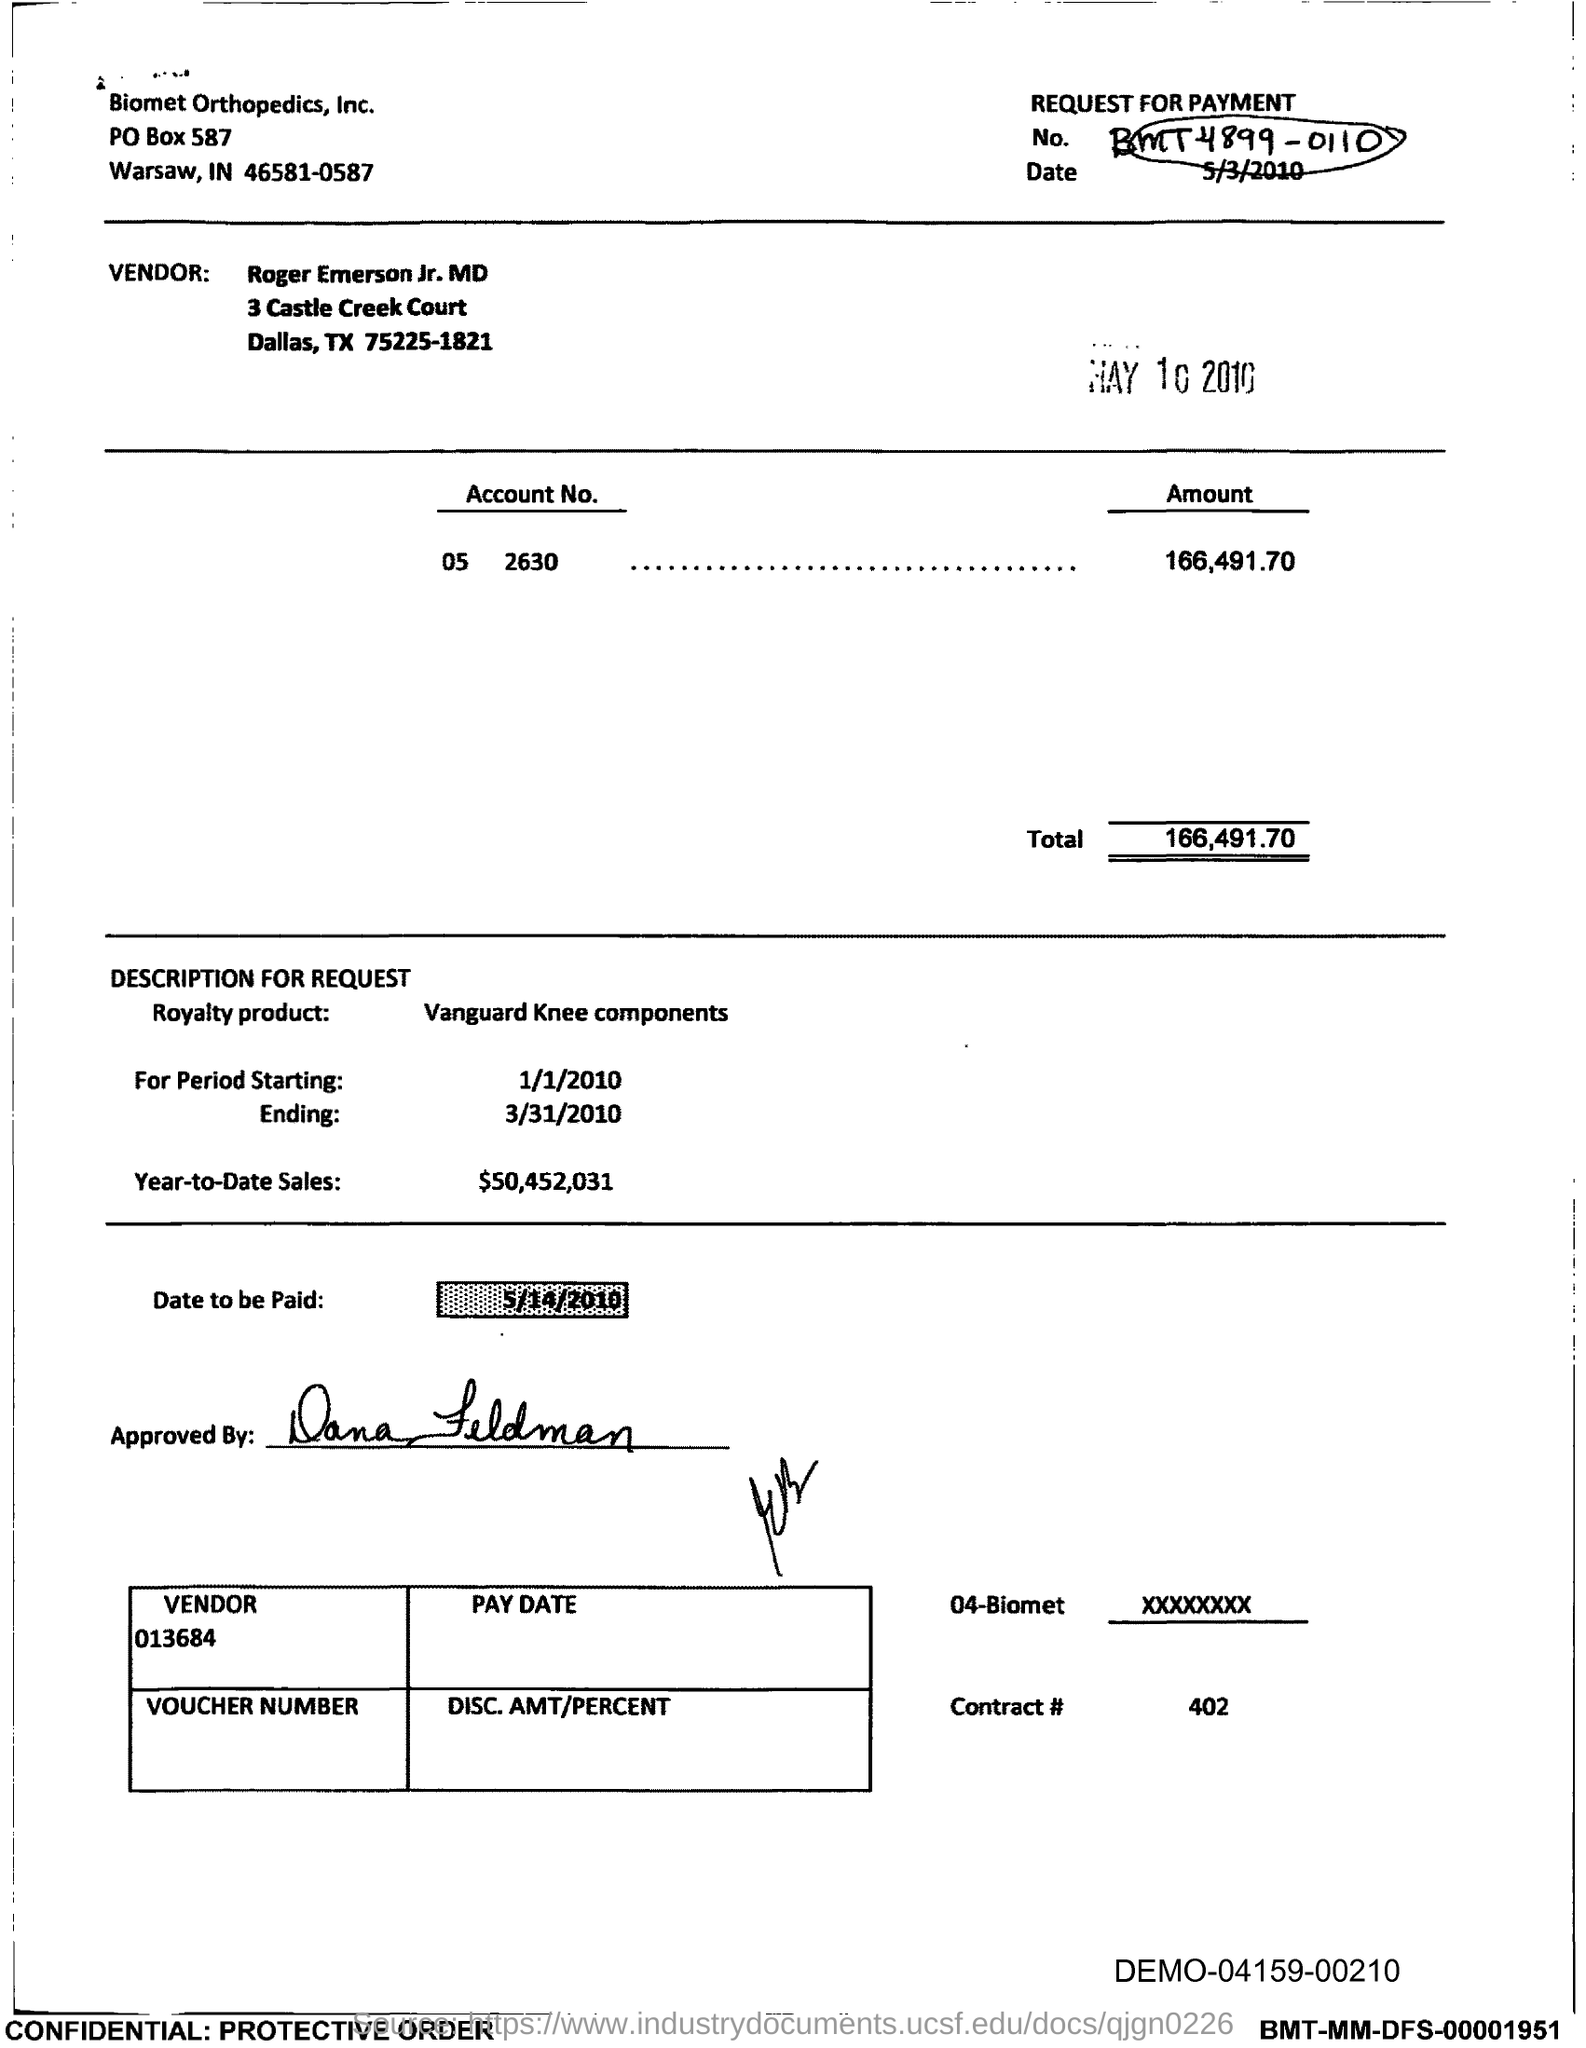Identify some key points in this picture. The voucher indicates an amount of 166,491.70... 